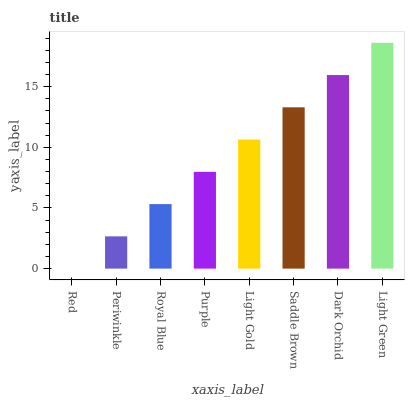Is Red the minimum?
Answer yes or no. Yes. Is Light Green the maximum?
Answer yes or no. Yes. Is Periwinkle the minimum?
Answer yes or no. No. Is Periwinkle the maximum?
Answer yes or no. No. Is Periwinkle greater than Red?
Answer yes or no. Yes. Is Red less than Periwinkle?
Answer yes or no. Yes. Is Red greater than Periwinkle?
Answer yes or no. No. Is Periwinkle less than Red?
Answer yes or no. No. Is Light Gold the high median?
Answer yes or no. Yes. Is Purple the low median?
Answer yes or no. Yes. Is Dark Orchid the high median?
Answer yes or no. No. Is Light Green the low median?
Answer yes or no. No. 